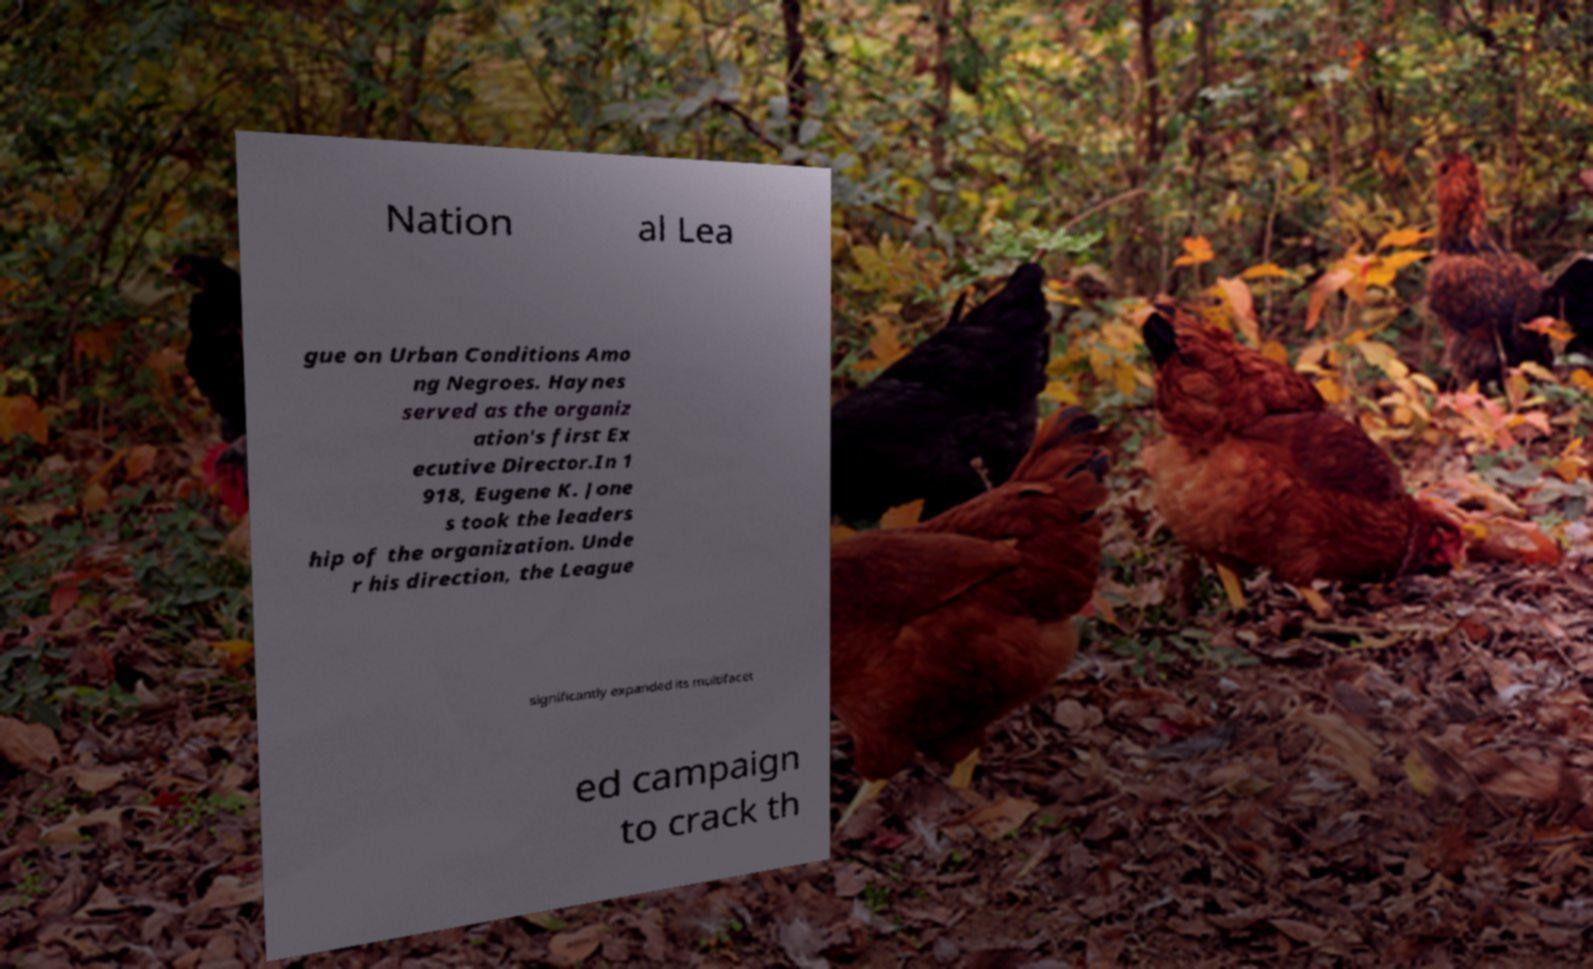Could you extract and type out the text from this image? Nation al Lea gue on Urban Conditions Amo ng Negroes. Haynes served as the organiz ation's first Ex ecutive Director.In 1 918, Eugene K. Jone s took the leaders hip of the organization. Unde r his direction, the League significantly expanded its multifacet ed campaign to crack th 